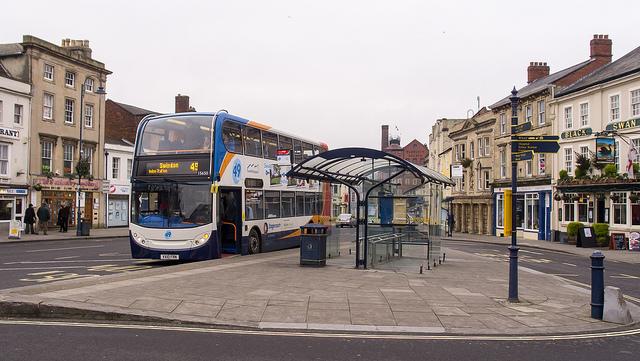What type of bus is this?
Answer briefly. Double decker. Is that a bus stop near the bus?
Write a very short answer. Yes. Can you sleep on this bus?
Quick response, please. Yes. 